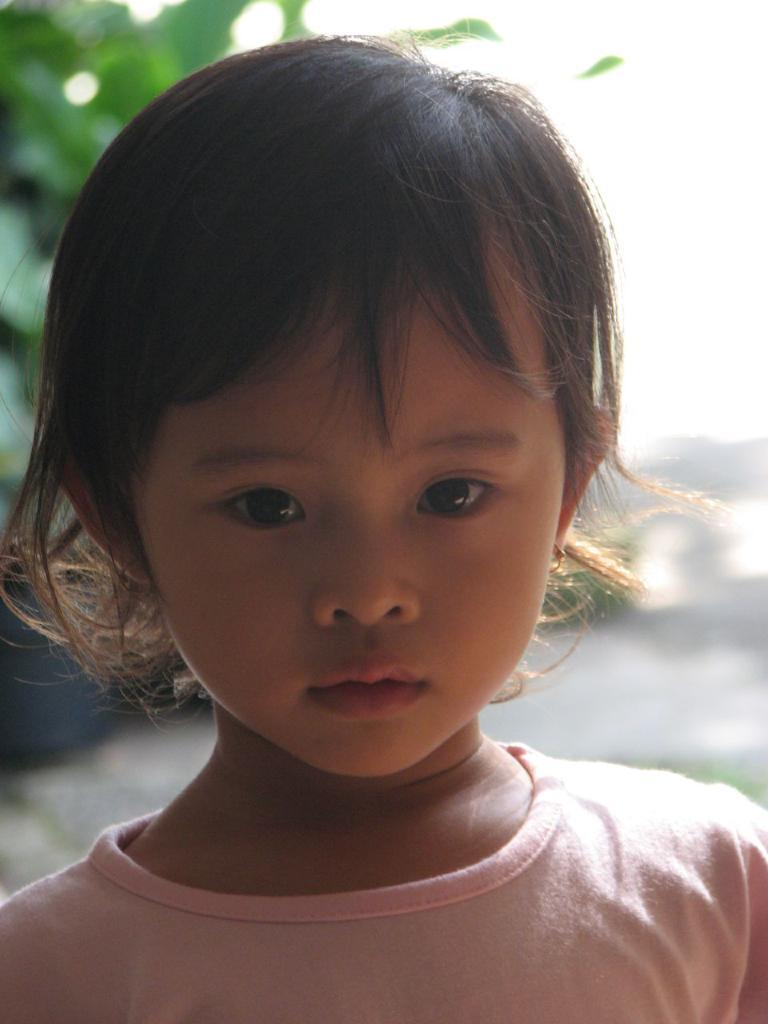What is present in the image? There is a person in the image. Can you describe the person's attire? The person is wearing a peach-colored dress. How would you describe the background of the image? The background of the image is blurred. What type of ink is being used by the fairies in the image? There are no fairies present in the image, so it is not possible to determine what type of ink they might be using. 